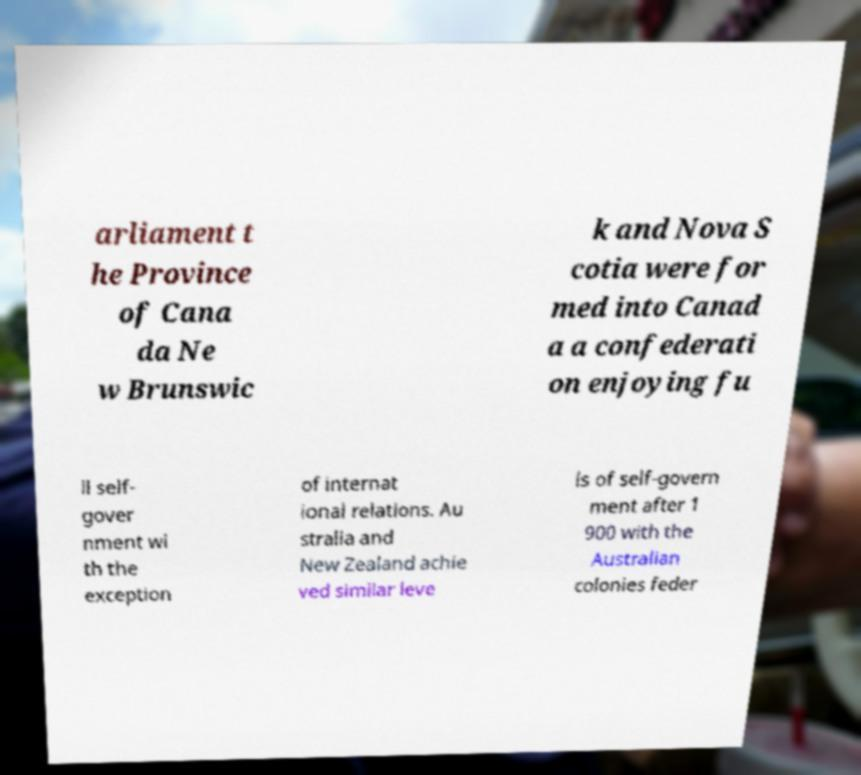Please identify and transcribe the text found in this image. arliament t he Province of Cana da Ne w Brunswic k and Nova S cotia were for med into Canad a a confederati on enjoying fu ll self- gover nment wi th the exception of internat ional relations. Au stralia and New Zealand achie ved similar leve ls of self-govern ment after 1 900 with the Australian colonies feder 